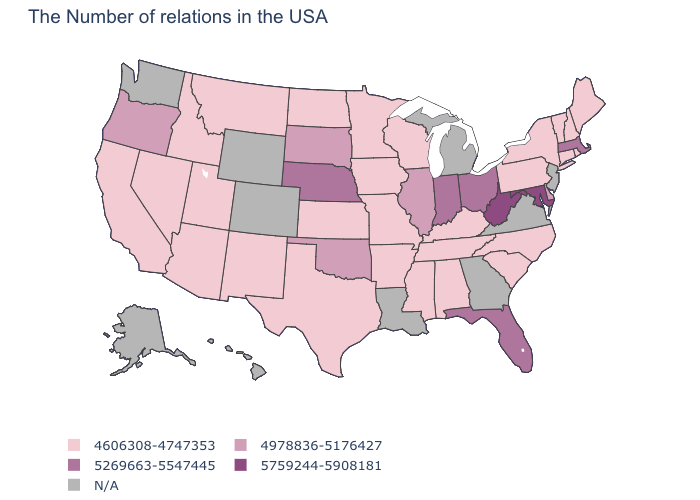Name the states that have a value in the range 5269663-5547445?
Write a very short answer. Massachusetts, Ohio, Florida, Indiana, Nebraska. Which states hav the highest value in the West?
Be succinct. Oregon. What is the lowest value in states that border Connecticut?
Write a very short answer. 4606308-4747353. Is the legend a continuous bar?
Give a very brief answer. No. Among the states that border Connecticut , which have the lowest value?
Concise answer only. Rhode Island, New York. Among the states that border Idaho , does Utah have the highest value?
Quick response, please. No. What is the lowest value in states that border New Hampshire?
Short answer required. 4606308-4747353. What is the lowest value in the South?
Concise answer only. 4606308-4747353. What is the value of Washington?
Keep it brief. N/A. Does Maryland have the highest value in the USA?
Short answer required. Yes. Does Massachusetts have the highest value in the Northeast?
Give a very brief answer. Yes. Name the states that have a value in the range 5759244-5908181?
Short answer required. Maryland, West Virginia. Which states have the lowest value in the USA?
Write a very short answer. Maine, Rhode Island, New Hampshire, Vermont, Connecticut, New York, Pennsylvania, North Carolina, South Carolina, Kentucky, Alabama, Tennessee, Wisconsin, Mississippi, Missouri, Arkansas, Minnesota, Iowa, Kansas, Texas, North Dakota, New Mexico, Utah, Montana, Arizona, Idaho, Nevada, California. What is the highest value in the West ?
Answer briefly. 4978836-5176427. Which states have the lowest value in the USA?
Be succinct. Maine, Rhode Island, New Hampshire, Vermont, Connecticut, New York, Pennsylvania, North Carolina, South Carolina, Kentucky, Alabama, Tennessee, Wisconsin, Mississippi, Missouri, Arkansas, Minnesota, Iowa, Kansas, Texas, North Dakota, New Mexico, Utah, Montana, Arizona, Idaho, Nevada, California. 